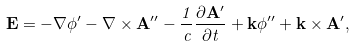Convert formula to latex. <formula><loc_0><loc_0><loc_500><loc_500>\mathbf E = - \nabla \phi ^ { \prime } - \nabla \times \mathbf A ^ { \prime \prime } - \frac { 1 } { c } \frac { \partial \mathbf A ^ { \prime } } { \partial t } + \mathbf k \phi ^ { \prime \prime } + \mathbf k \times \mathbf A ^ { \prime } ,</formula> 